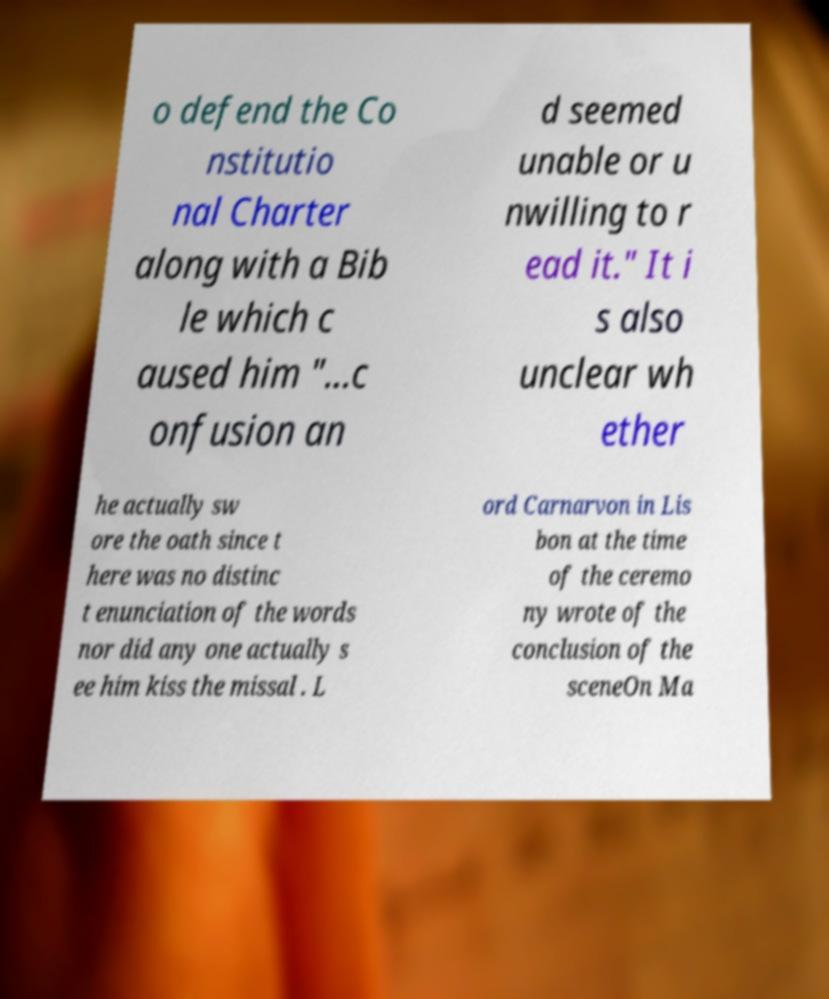Can you accurately transcribe the text from the provided image for me? o defend the Co nstitutio nal Charter along with a Bib le which c aused him "...c onfusion an d seemed unable or u nwilling to r ead it." It i s also unclear wh ether he actually sw ore the oath since t here was no distinc t enunciation of the words nor did any one actually s ee him kiss the missal . L ord Carnarvon in Lis bon at the time of the ceremo ny wrote of the conclusion of the sceneOn Ma 